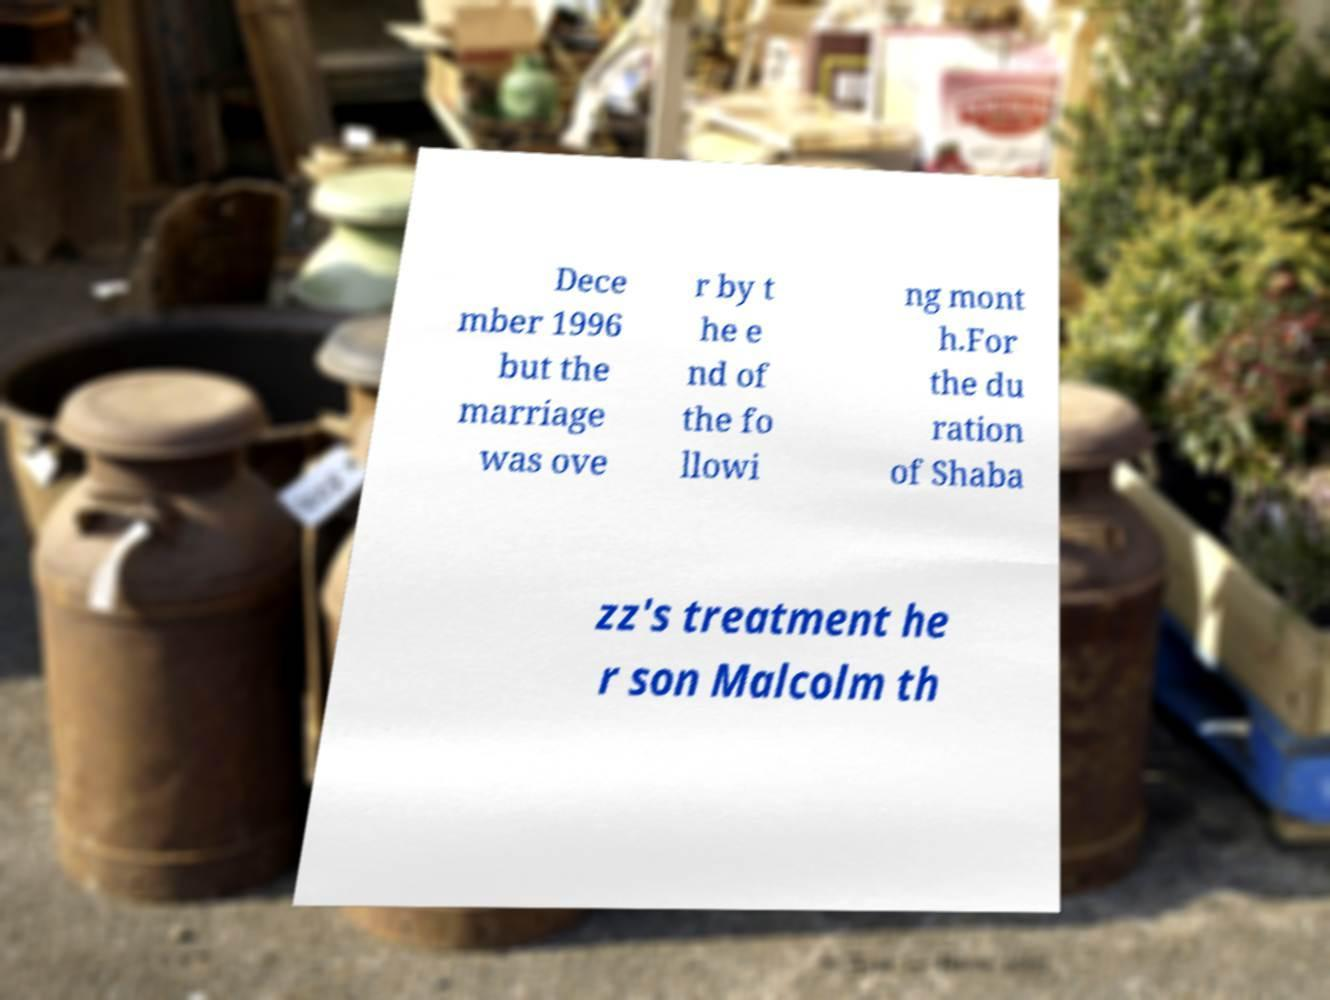Could you extract and type out the text from this image? Dece mber 1996 but the marriage was ove r by t he e nd of the fo llowi ng mont h.For the du ration of Shaba zz's treatment he r son Malcolm th 